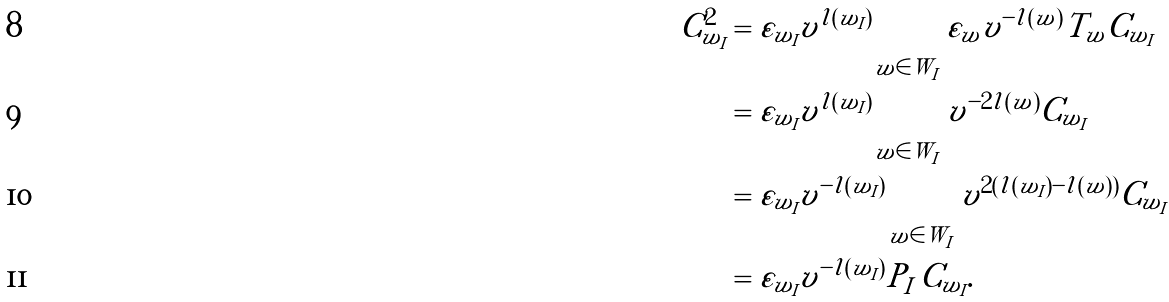Convert formula to latex. <formula><loc_0><loc_0><loc_500><loc_500>C _ { w _ { I } } ^ { 2 } & = \varepsilon _ { w _ { I } } v ^ { l ( w _ { I } ) } \sum _ { w \in W _ { I } } \varepsilon _ { w } v ^ { - l ( w ) } T _ { w } C _ { w _ { I } } \\ & = \varepsilon _ { w _ { I } } v ^ { l ( w _ { I } ) } \sum _ { w \in W _ { I } } v ^ { - 2 l ( w ) } C _ { w _ { I } } \\ & = \varepsilon _ { w _ { I } } v ^ { - l ( w _ { I } ) } \sum _ { w \in W _ { I } } v ^ { 2 ( l ( w _ { I } ) - l ( w ) ) } C _ { w _ { I } } \\ & = \varepsilon _ { w _ { I } } v ^ { - l ( w _ { I } ) } P _ { I } \, C _ { w _ { I } } .</formula> 